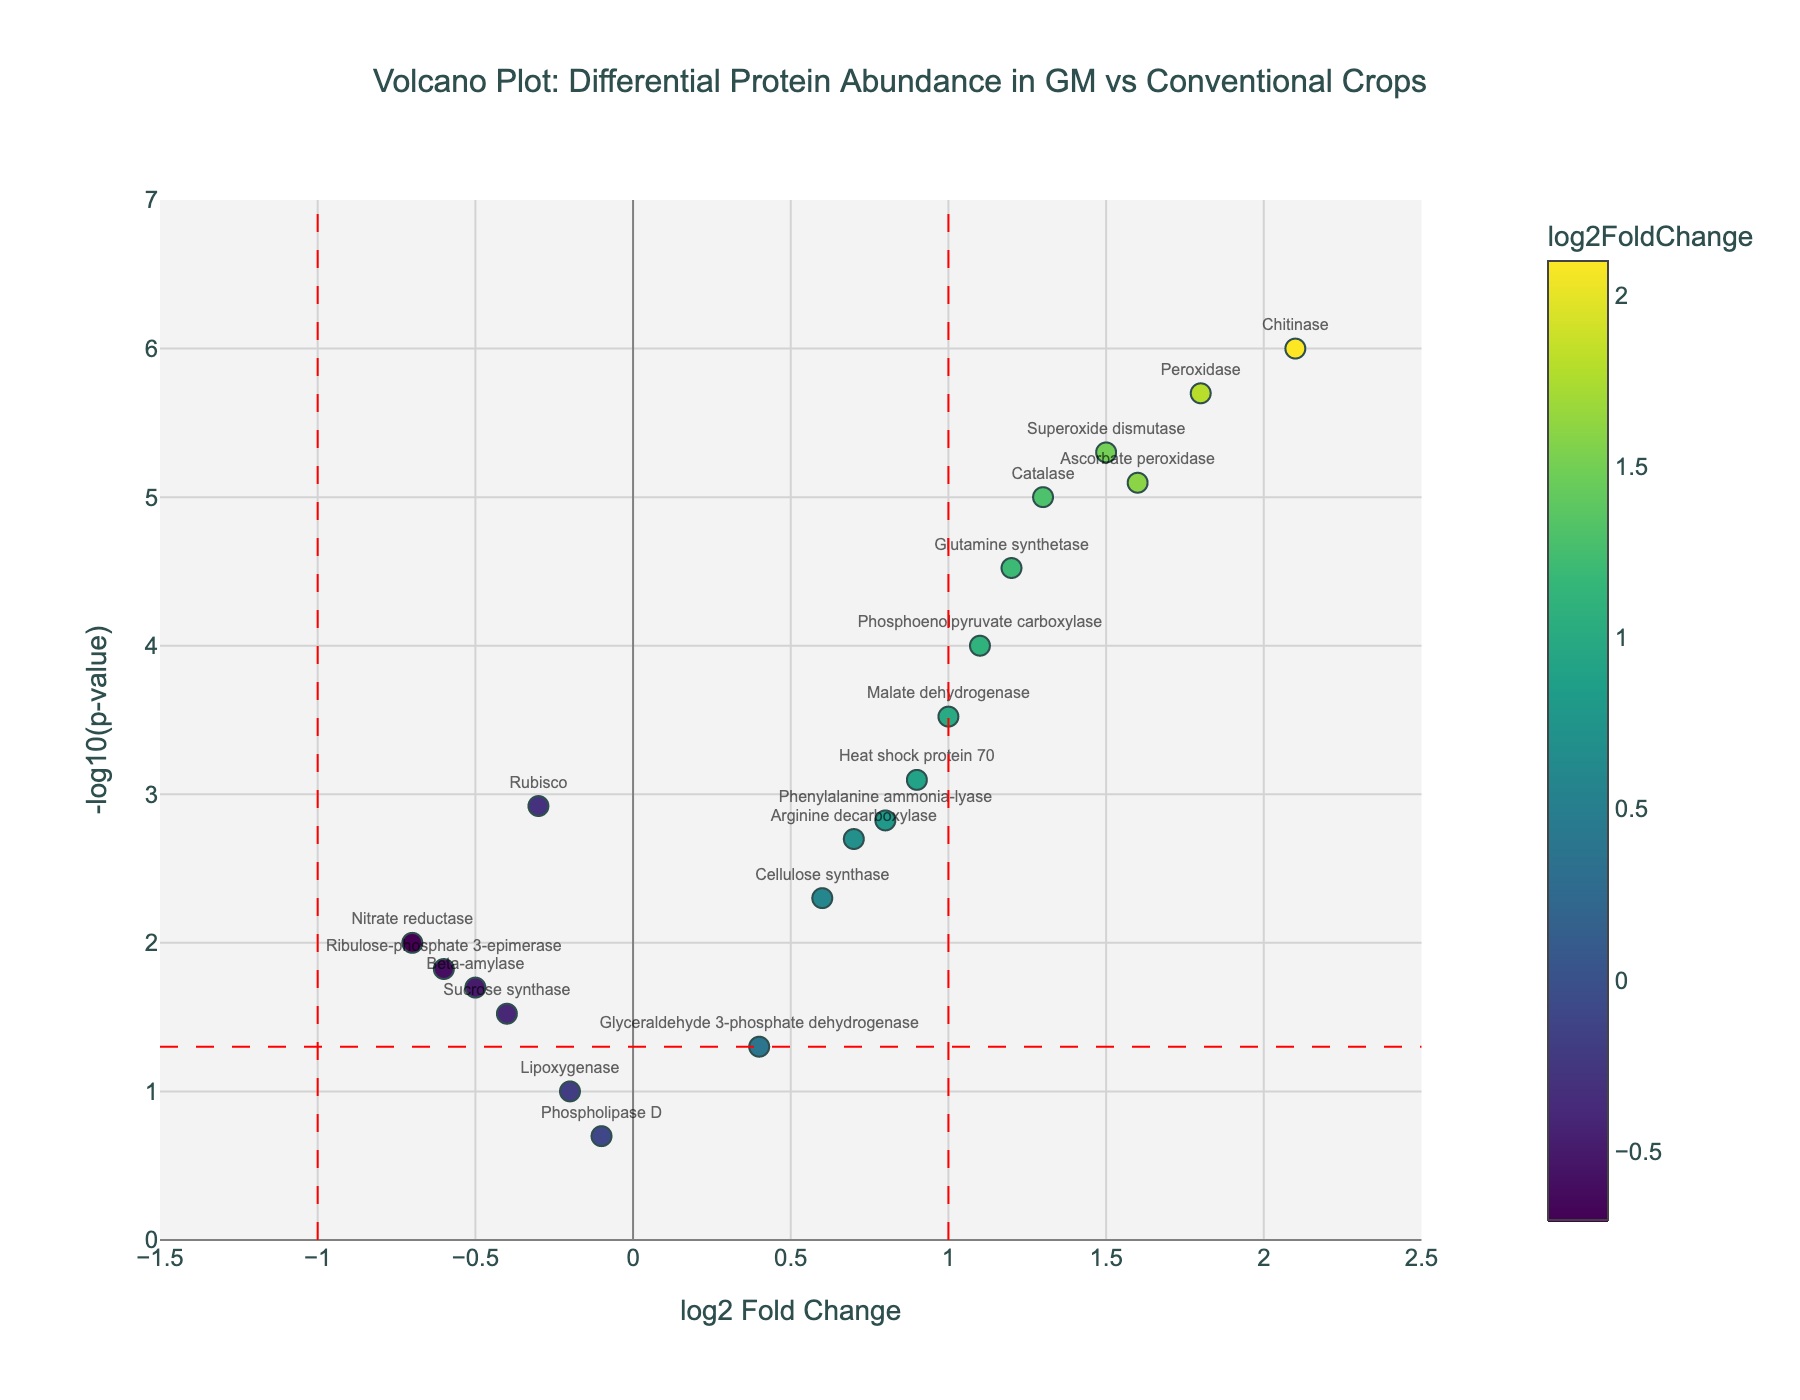What does the title of the plot say? The title of the plot is usually displayed at the top center of the figure. It communicates the primary focus of the visualization, ensuring viewers have a clear understanding of the data being presented. In this case, the title reads "Volcano Plot: Differential Protein Abundance in GM vs Conventional Crops".
Answer: Volcano Plot: Differential Protein Abundance in GM vs Conventional Crops What do the x-axis and y-axis represent? Axes are fundamental to interpreting any plot. In this figure, the x-axis represents the "log2 Fold Change", and the y-axis represents "-log10(p-value)". These labels indicate the type of quantitative relationship shown in the plot.
Answer: log2 Fold Change and -log10(p-value) Which protein has the most significant increase in abundance in GM crops compared to conventional crops? To find this, locate the point farthest to the right (highest log2 Fold Change) and highest on the y-axis (lowest p-value). The point for Chitinase has the highest values.
Answer: Chitinase How many proteins have a -log10(p-value) greater than 5? Count the number of points that lie above the horizontal line representing -log10(0.05) and beyond a y-axis value of 5. Chitinase, Peroxidase, and Ascorbate peroxidase are these proteins.
Answer: 3 What is the log2 Fold Change range in the plot? Review the x-axis to find the smallest and largest values. From the plot settings, the range is approximately from -1.5 to 2.5.
Answer: -1.5 to 2.5 Which protein shows a significant decrease in abundance with a log2 Fold Change less than -0.5? Look for points on the left side of the plot (negative log2 Fold Change), below the vertical line at -1, and above the horizontal line at about -1.3. Beta-amylase and Ribulose-phosphate 3-epimerase are candidates. Ribulose-phosphate 3-epimerase meets both criteria.
Answer: Ribulose-phosphate 3-epimerase Compare the abundances of Heat shock protein 70 and Glutamine synthetase. Which has a higher log2 Fold Change? Refer to the x-axis positions of these proteins. Glutamine synthetase is positioned at 1.2, and Heat shock protein 70 is at 0.9. Therefore, Glutamine synthetase has a higher log2 Fold Change.
Answer: Glutamine synthetase What is the -log10(p-value) for Nitrate reductase? Locate Nitrate reductase on the plot and read its y-axis value. This value represents -log10(p-value). Nitrate reductase is positioned around this value on the y-axis.
Answer: 2 Identify two proteins with similar p-values but markedly different log2 Fold Changes. Examine closely grouped data points along the y-axis and compare their x-axis positions. Arginine decarboxylase and Cellulose synthase have comparable y-axis values but different x-axis positions, giving them similar p-values but different log2 Fold Changes.
Answer: Arginine decarboxylase, Cellulose synthase 